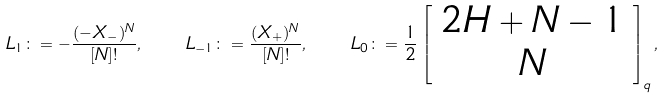<formula> <loc_0><loc_0><loc_500><loc_500>L _ { 1 } \colon = - \frac { ( - X _ { - } ) ^ { N } } { [ N ] ! } , \quad L _ { - 1 } \colon = \frac { ( X _ { + } ) ^ { N } } { [ N ] ! } , \quad L _ { 0 } \colon = \frac { 1 } { 2 } \left [ \begin{array} { c } 2 H + N - 1 \\ N \end{array} \right ] _ { q } ,</formula> 